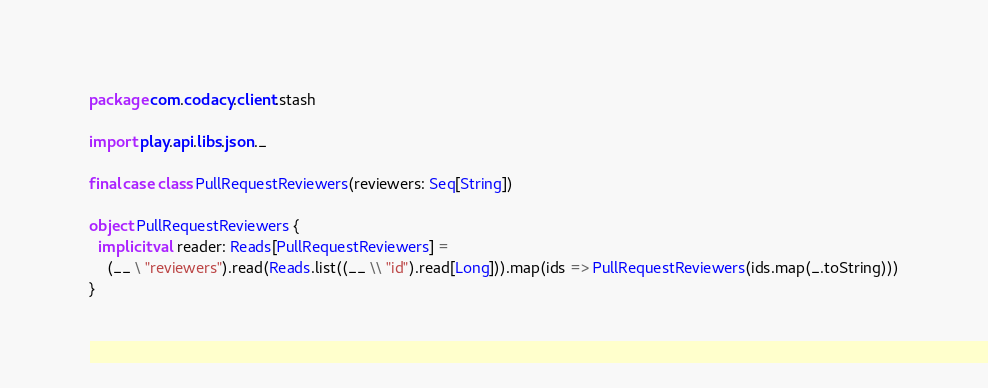<code> <loc_0><loc_0><loc_500><loc_500><_Scala_>package com.codacy.client.stash

import play.api.libs.json._

final case class PullRequestReviewers(reviewers: Seq[String])

object PullRequestReviewers {
  implicit val reader: Reads[PullRequestReviewers] =
    (__ \ "reviewers").read(Reads.list((__ \\ "id").read[Long])).map(ids => PullRequestReviewers(ids.map(_.toString)))
}
</code> 